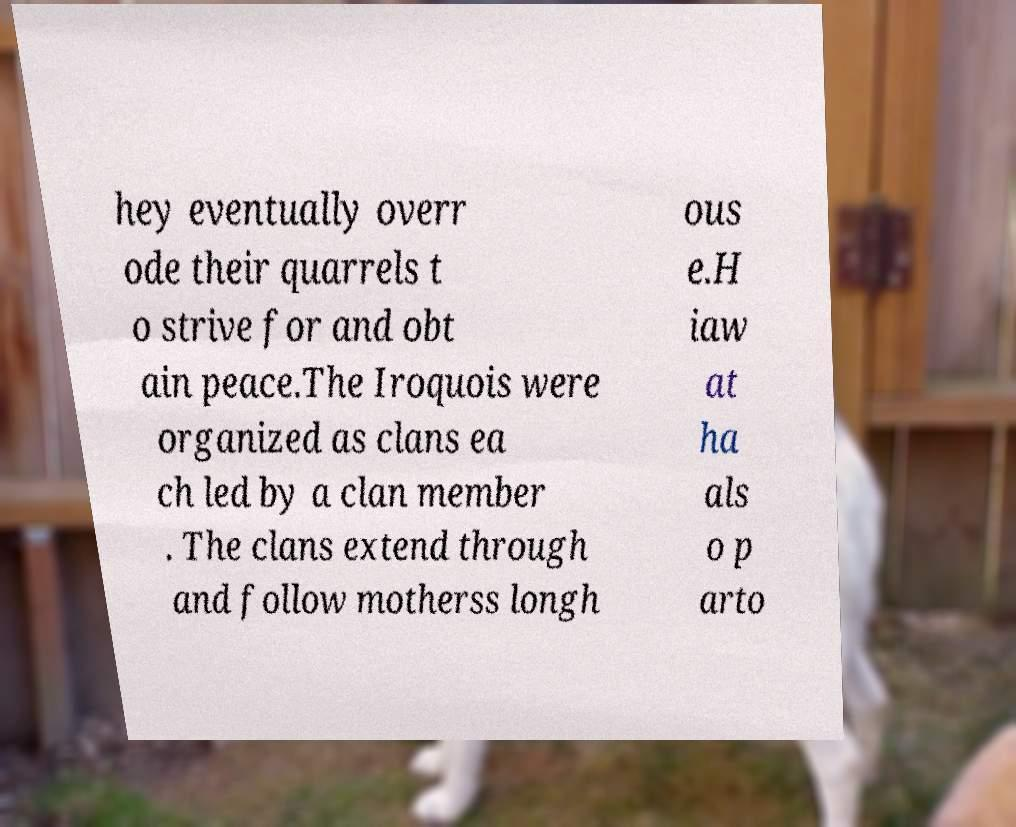Please identify and transcribe the text found in this image. hey eventually overr ode their quarrels t o strive for and obt ain peace.The Iroquois were organized as clans ea ch led by a clan member . The clans extend through and follow motherss longh ous e.H iaw at ha als o p arto 